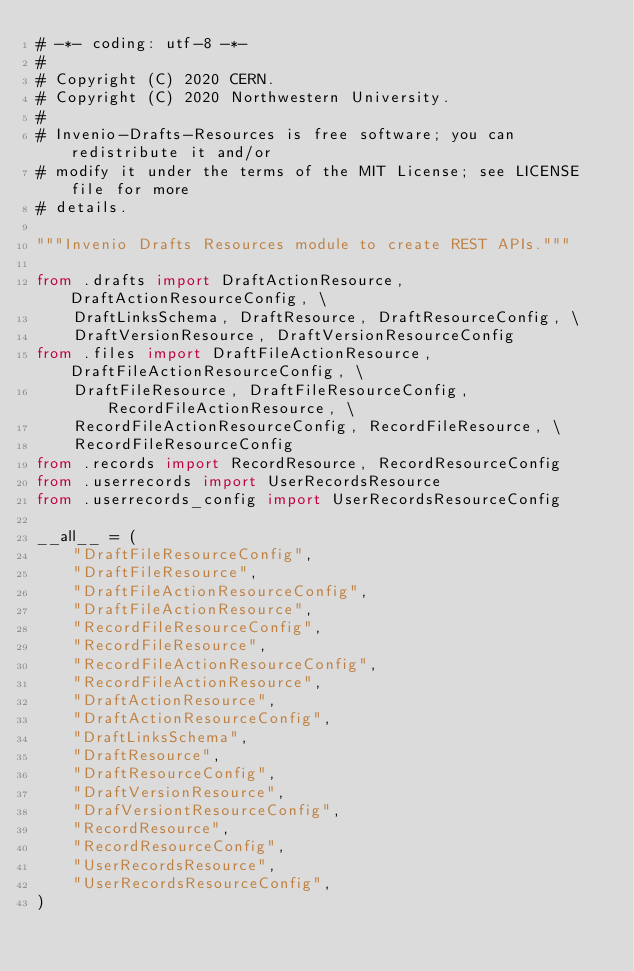Convert code to text. <code><loc_0><loc_0><loc_500><loc_500><_Python_># -*- coding: utf-8 -*-
#
# Copyright (C) 2020 CERN.
# Copyright (C) 2020 Northwestern University.
#
# Invenio-Drafts-Resources is free software; you can redistribute it and/or
# modify it under the terms of the MIT License; see LICENSE file for more
# details.

"""Invenio Drafts Resources module to create REST APIs."""

from .drafts import DraftActionResource, DraftActionResourceConfig, \
    DraftLinksSchema, DraftResource, DraftResourceConfig, \
    DraftVersionResource, DraftVersionResourceConfig
from .files import DraftFileActionResource, DraftFileActionResourceConfig, \
    DraftFileResource, DraftFileResourceConfig, RecordFileActionResource, \
    RecordFileActionResourceConfig, RecordFileResource, \
    RecordFileResourceConfig
from .records import RecordResource, RecordResourceConfig
from .userrecords import UserRecordsResource
from .userrecords_config import UserRecordsResourceConfig

__all__ = (
    "DraftFileResourceConfig",
    "DraftFileResource",
    "DraftFileActionResourceConfig",
    "DraftFileActionResource",
    "RecordFileResourceConfig",
    "RecordFileResource",
    "RecordFileActionResourceConfig",
    "RecordFileActionResource",
    "DraftActionResource",
    "DraftActionResourceConfig",
    "DraftLinksSchema",
    "DraftResource",
    "DraftResourceConfig",
    "DraftVersionResource",
    "DrafVersiontResourceConfig",
    "RecordResource",
    "RecordResourceConfig",
    "UserRecordsResource",
    "UserRecordsResourceConfig",
)
</code> 